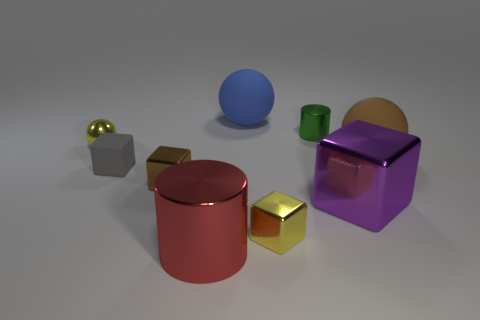Add 1 large gray shiny blocks. How many objects exist? 10 Subtract all cubes. How many objects are left? 5 Add 3 large purple objects. How many large purple objects exist? 4 Subtract 1 yellow balls. How many objects are left? 8 Subtract all small green rubber cylinders. Subtract all red metallic things. How many objects are left? 8 Add 1 small green cylinders. How many small green cylinders are left? 2 